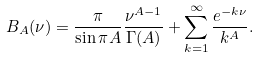Convert formula to latex. <formula><loc_0><loc_0><loc_500><loc_500>B _ { A } ( \nu ) = \frac { \pi } { \sin \pi A } \frac { \nu ^ { A - 1 } } { \Gamma ( A ) } + \sum _ { k = 1 } ^ { \infty } \frac { e ^ { - k \nu } } { k ^ { A } } .</formula> 